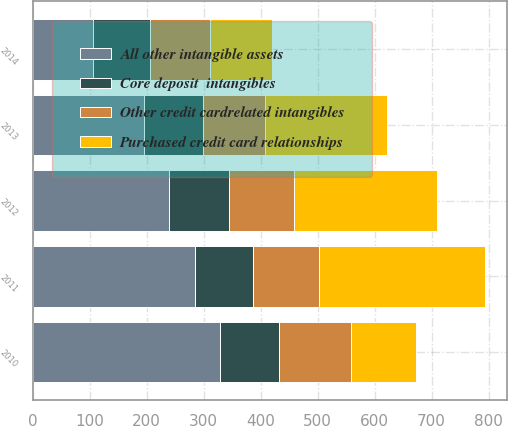<chart> <loc_0><loc_0><loc_500><loc_500><stacked_bar_chart><ecel><fcel>2010<fcel>2011<fcel>2012<fcel>2013<fcel>2014<nl><fcel>Purchased credit card relationships<fcel>113<fcel>290<fcel>252<fcel>213<fcel>109<nl><fcel>Core deposit  intangibles<fcel>103<fcel>102<fcel>105<fcel>104<fcel>100<nl><fcel>All other intangible assets<fcel>329<fcel>284<fcel>240<fcel>195<fcel>106<nl><fcel>Other credit cardrelated intangibles<fcel>127<fcel>117<fcel>113<fcel>109<fcel>105<nl></chart> 